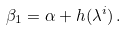Convert formula to latex. <formula><loc_0><loc_0><loc_500><loc_500>\beta _ { 1 } = \alpha + h ( \lambda ^ { i } ) \, .</formula> 